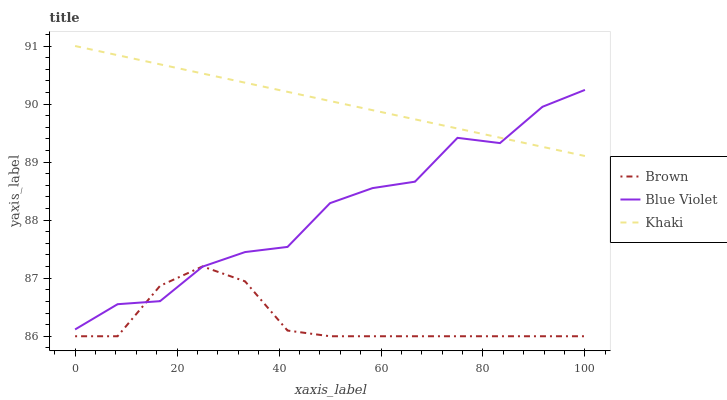Does Brown have the minimum area under the curve?
Answer yes or no. Yes. Does Khaki have the maximum area under the curve?
Answer yes or no. Yes. Does Blue Violet have the minimum area under the curve?
Answer yes or no. No. Does Blue Violet have the maximum area under the curve?
Answer yes or no. No. Is Khaki the smoothest?
Answer yes or no. Yes. Is Blue Violet the roughest?
Answer yes or no. Yes. Is Blue Violet the smoothest?
Answer yes or no. No. Is Khaki the roughest?
Answer yes or no. No. Does Brown have the lowest value?
Answer yes or no. Yes. Does Blue Violet have the lowest value?
Answer yes or no. No. Does Khaki have the highest value?
Answer yes or no. Yes. Does Blue Violet have the highest value?
Answer yes or no. No. Is Brown less than Khaki?
Answer yes or no. Yes. Is Khaki greater than Brown?
Answer yes or no. Yes. Does Blue Violet intersect Brown?
Answer yes or no. Yes. Is Blue Violet less than Brown?
Answer yes or no. No. Is Blue Violet greater than Brown?
Answer yes or no. No. Does Brown intersect Khaki?
Answer yes or no. No. 